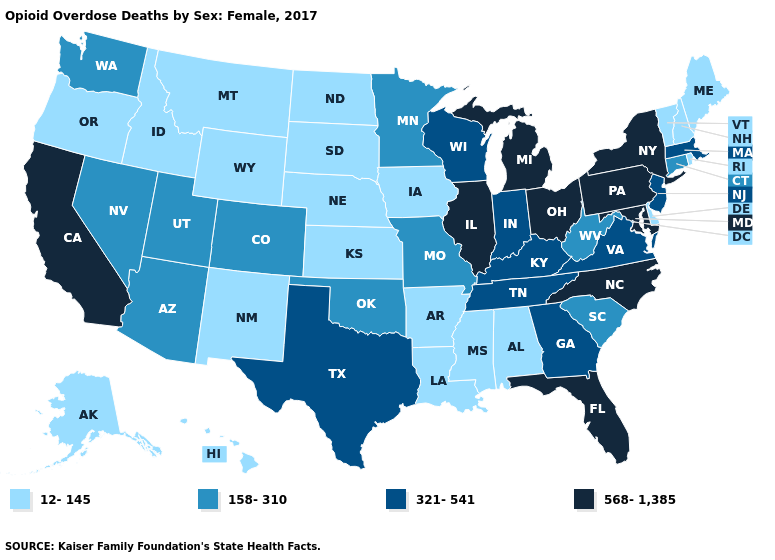Does Utah have the highest value in the West?
Answer briefly. No. Does the map have missing data?
Be succinct. No. Which states have the lowest value in the USA?
Write a very short answer. Alabama, Alaska, Arkansas, Delaware, Hawaii, Idaho, Iowa, Kansas, Louisiana, Maine, Mississippi, Montana, Nebraska, New Hampshire, New Mexico, North Dakota, Oregon, Rhode Island, South Dakota, Vermont, Wyoming. What is the value of Indiana?
Be succinct. 321-541. What is the lowest value in the South?
Be succinct. 12-145. Name the states that have a value in the range 158-310?
Short answer required. Arizona, Colorado, Connecticut, Minnesota, Missouri, Nevada, Oklahoma, South Carolina, Utah, Washington, West Virginia. Does the first symbol in the legend represent the smallest category?
Answer briefly. Yes. What is the value of Connecticut?
Answer briefly. 158-310. What is the highest value in the USA?
Write a very short answer. 568-1,385. Name the states that have a value in the range 12-145?
Write a very short answer. Alabama, Alaska, Arkansas, Delaware, Hawaii, Idaho, Iowa, Kansas, Louisiana, Maine, Mississippi, Montana, Nebraska, New Hampshire, New Mexico, North Dakota, Oregon, Rhode Island, South Dakota, Vermont, Wyoming. Does Arizona have the lowest value in the USA?
Quick response, please. No. Name the states that have a value in the range 321-541?
Answer briefly. Georgia, Indiana, Kentucky, Massachusetts, New Jersey, Tennessee, Texas, Virginia, Wisconsin. Name the states that have a value in the range 158-310?
Quick response, please. Arizona, Colorado, Connecticut, Minnesota, Missouri, Nevada, Oklahoma, South Carolina, Utah, Washington, West Virginia. Does California have the highest value in the West?
Concise answer only. Yes. Among the states that border Louisiana , does Mississippi have the lowest value?
Write a very short answer. Yes. 